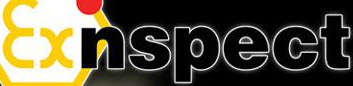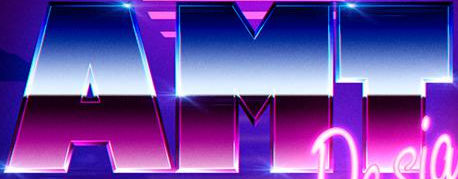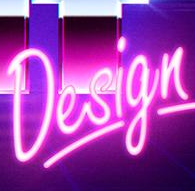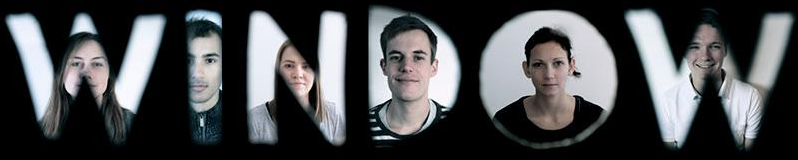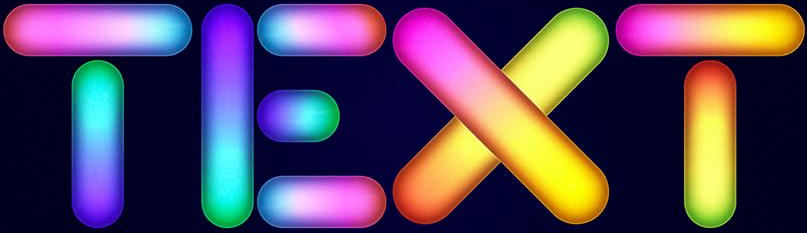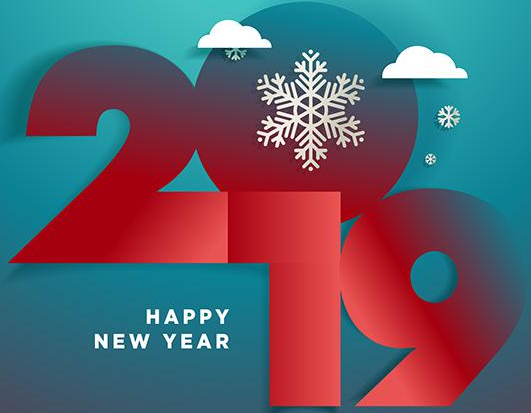Transcribe the words shown in these images in order, separated by a semicolon. Exnspect; AMT; Design; WINDOW; TEXT; 2019 